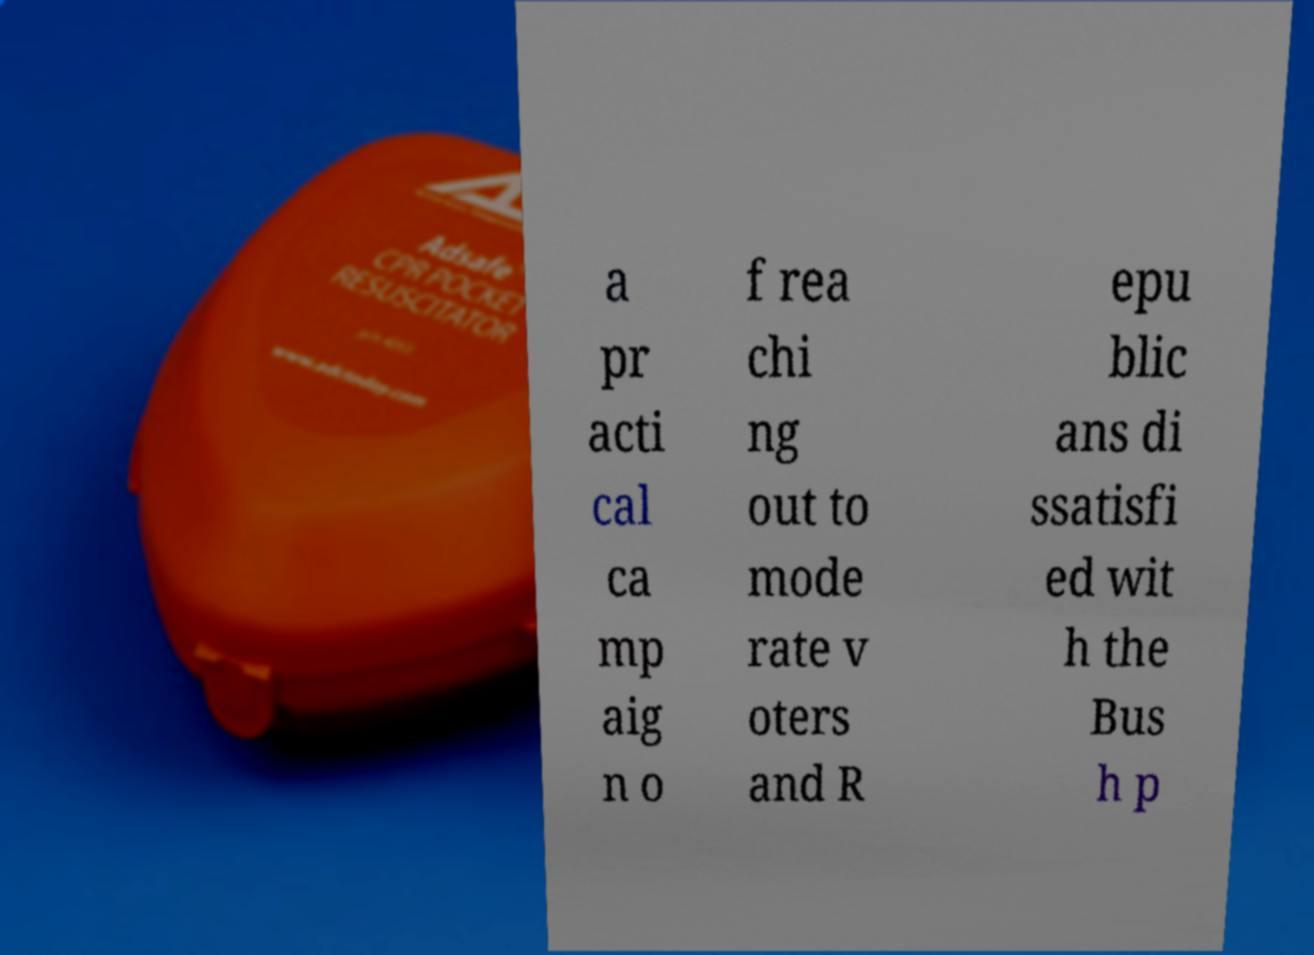Could you assist in decoding the text presented in this image and type it out clearly? a pr acti cal ca mp aig n o f rea chi ng out to mode rate v oters and R epu blic ans di ssatisfi ed wit h the Bus h p 